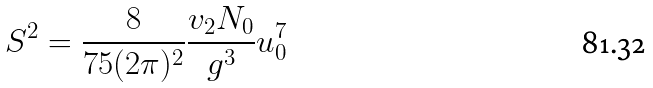<formula> <loc_0><loc_0><loc_500><loc_500>S ^ { 2 } = \frac { 8 } { 7 5 ( 2 \pi ) ^ { 2 } } \frac { v _ { 2 } N _ { 0 } } { g ^ { 3 } } u _ { 0 } ^ { 7 }</formula> 